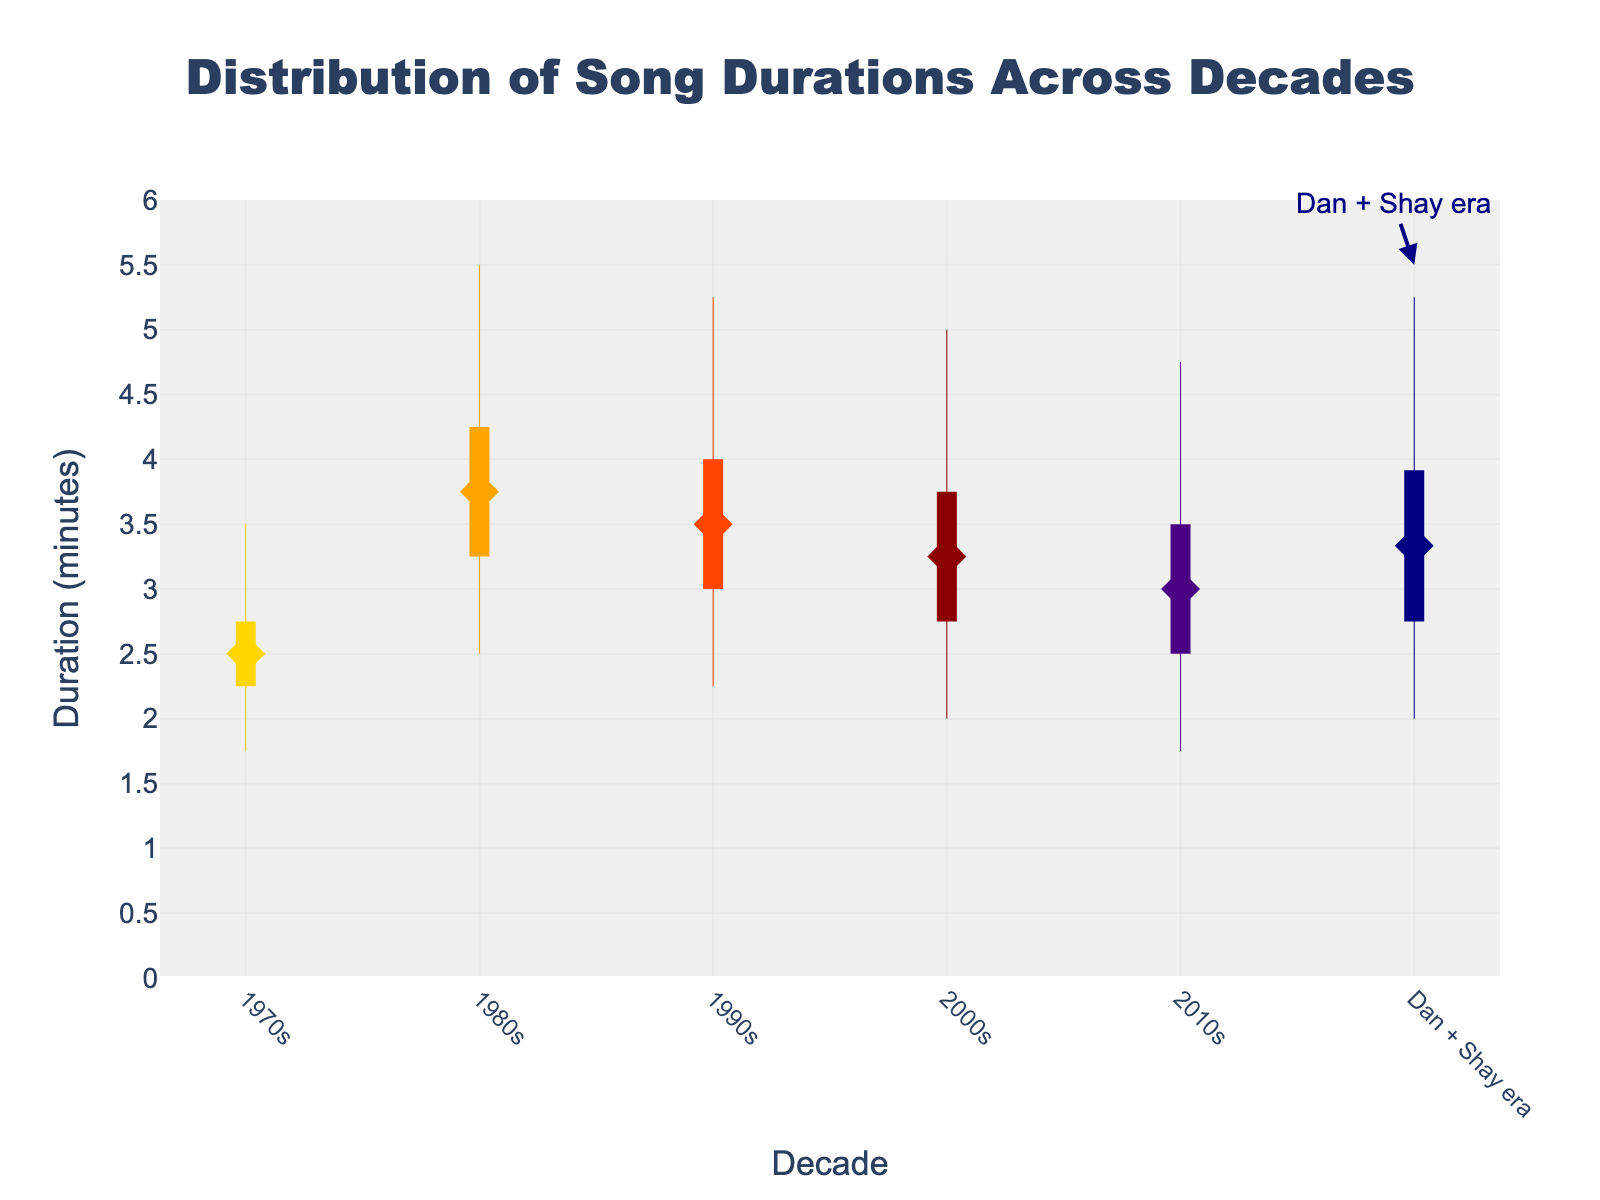What's the title of the figure? The title of the figure is located at the top and is often in a larger and bold font to stand out.
Answer: Distribution of Song Durations Across Decades Which decade has the smallest minimum song duration? Look at the lowest points (bottom markers) for each decade and identify the one with the smallest value.
Answer: 1970s What is the median song duration in the 2000s? The median value is represented by a diamond marker in the middle of each decade's vertical line. Check the position of the 2000s' diamond marker.
Answer: 3:15 How does the song duration range of the 1980s compare to that of the Dan + Shay era? Determine the range by subtracting the minimum value from the maximum value for both the 1980s and the Dan + Shay era (5:30 - 2:30 and 5:15 - 2:00 respectively). Compare these ranges.
Answer: 1980s has a larger range Which decade has the highest median song duration? Identify the diamond marker that is located at the highest point on the y-axis.
Answer: 1980s How does the interquartile range (IQR) of the 1990s compare to that of the 2010s? The IQR is the difference between the Q3 and Q1 values. Calculate the IQR for both decades (4:00 - 3:00 and 3:30 - 2:30 respectively) and compare them.
Answer: 1990s have a larger IQR What is the maximum song duration in the 2010s? Find the highest point in the vertical line corresponding to the 2010s.
Answer: 4:45 Are song durations in the Dan + Shay era generally longer, shorter, or about the same as those in the 2000s? Compare the median, minimum, maximum, and IQR values between the Dan + Shay era and the 2000s. Note similarities or differences in these values.
Answer: About the same Which decade shows the most consistency in song durations, based on the range and IQR? The decade with the smallest range (Min to Max) and IQR (Q1 to Q3) is the most consistent. Compare these ranges across all decades.
Answer: 1970s How does the median song duration of the 2010s compare to the 1990s? Look at the diamond markers for both the 2010s and 1990s and compare their y-axis positions.
Answer: 2010s has a shorter median duration 